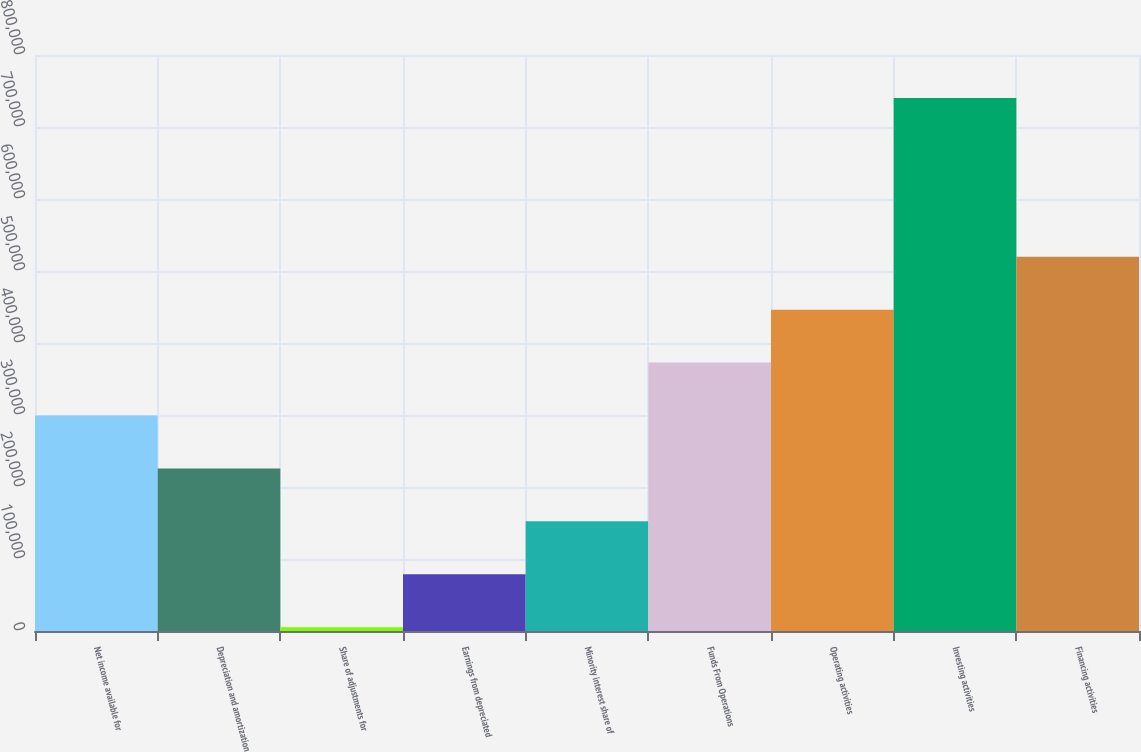Convert chart to OTSL. <chart><loc_0><loc_0><loc_500><loc_500><bar_chart><fcel>Net income available for<fcel>Depreciation and amortization<fcel>Share of adjustments for<fcel>Earnings from depreciated<fcel>Minority interest share of<fcel>Funds From Operations<fcel>Operating activities<fcel>Investing activities<fcel>Financing activities<nl><fcel>299268<fcel>225768<fcel>5268<fcel>78768.1<fcel>152268<fcel>372768<fcel>446269<fcel>740269<fcel>519769<nl></chart> 